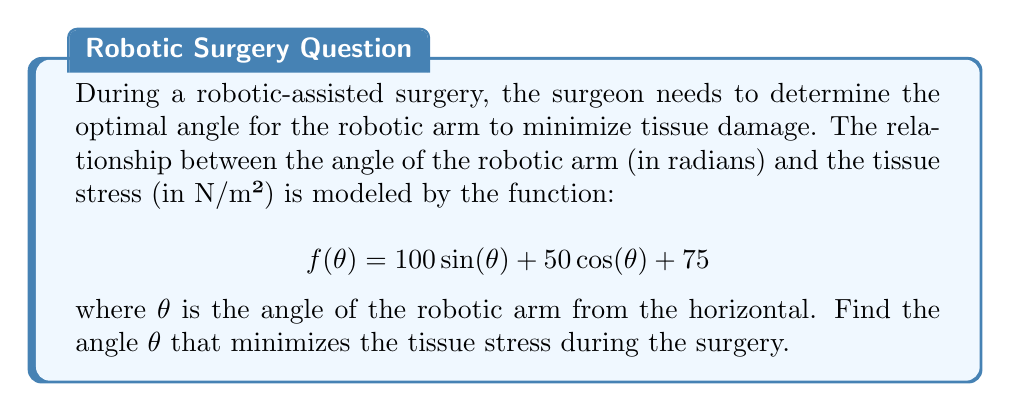Can you solve this math problem? To find the angle that minimizes the tissue stress, we need to find the minimum of the function $f(\theta)$. This can be done by following these steps:

1. Find the derivative of $f(\theta)$:
   $$f'(\theta) = 100\cos(\theta) - 50\sin(\theta)$$

2. Set the derivative equal to zero and solve for $\theta$:
   $$\begin{align}
   100\cos(\theta) - 50\sin(\theta) &= 0 \\
   2\cos(\theta) &= \sin(\theta) \\
   \tan(\theta) &= 2
   \end{align}$$

3. Use the inverse tangent function to solve for $\theta$:
   $$\theta = \arctan(2)$$

4. To confirm this is a minimum (not a maximum), check the second derivative:
   $$f''(\theta) = -100\sin(\theta) - 50\cos(\theta)$$
   
   Evaluating at $\theta = \arctan(2)$:
   $$\begin{align}
   f''(\arctan(2)) &= -100\sin(\arctan(2)) - 50\cos(\arctan(2)) \\
   &= -100 \cdot \frac{2}{\sqrt{5}} - 50 \cdot \frac{1}{\sqrt{5}} \\
   &= -\frac{250}{\sqrt{5}} < 0
   \end{align}$$

   Since the second derivative is negative at this point, it confirms that this is indeed a local minimum.

5. Convert the result to degrees for practical application:
   $$\theta_{degrees} = \arctan(2) \cdot \frac{180}{\pi} \approx 63.4349°$$

Therefore, the optimal angle for the robotic arm to minimize tissue stress during the surgery is approximately 63.4349 degrees from the horizontal.
Answer: The optimal angle $\theta$ that minimizes tissue stress is $\arctan(2)$ radians, or approximately 63.4349 degrees. 